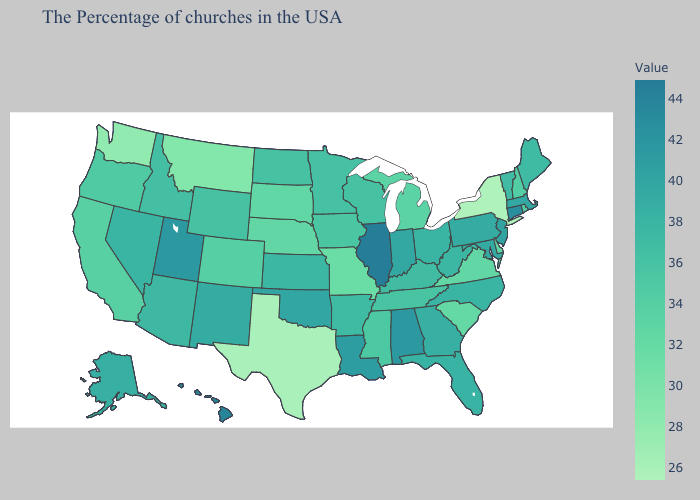Does New York have the lowest value in the USA?
Give a very brief answer. Yes. Which states have the lowest value in the MidWest?
Be succinct. Missouri. Does California have a higher value than Utah?
Concise answer only. No. Does Utah have the lowest value in the West?
Quick response, please. No. 